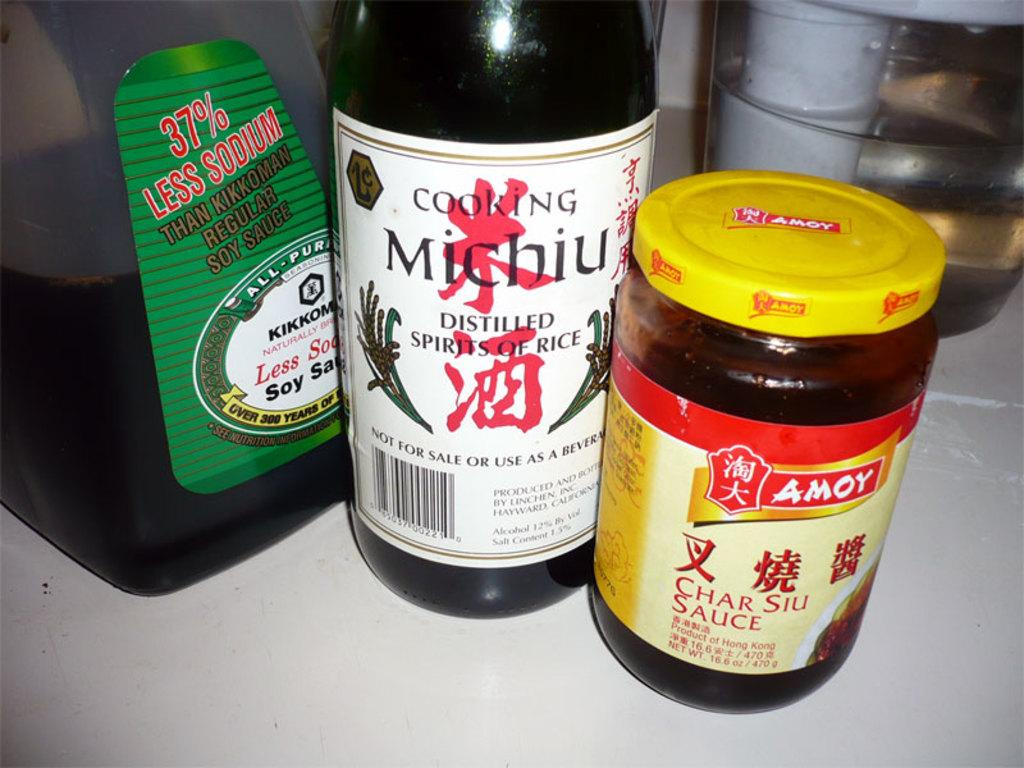<image>
Share a concise interpretation of the image provided. A jar of char siu sauce is from the Amoy brand. 